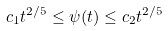Convert formula to latex. <formula><loc_0><loc_0><loc_500><loc_500>c _ { 1 } t ^ { 2 / 5 } \leq \psi ( t ) \leq c _ { 2 } t ^ { 2 / 5 }</formula> 